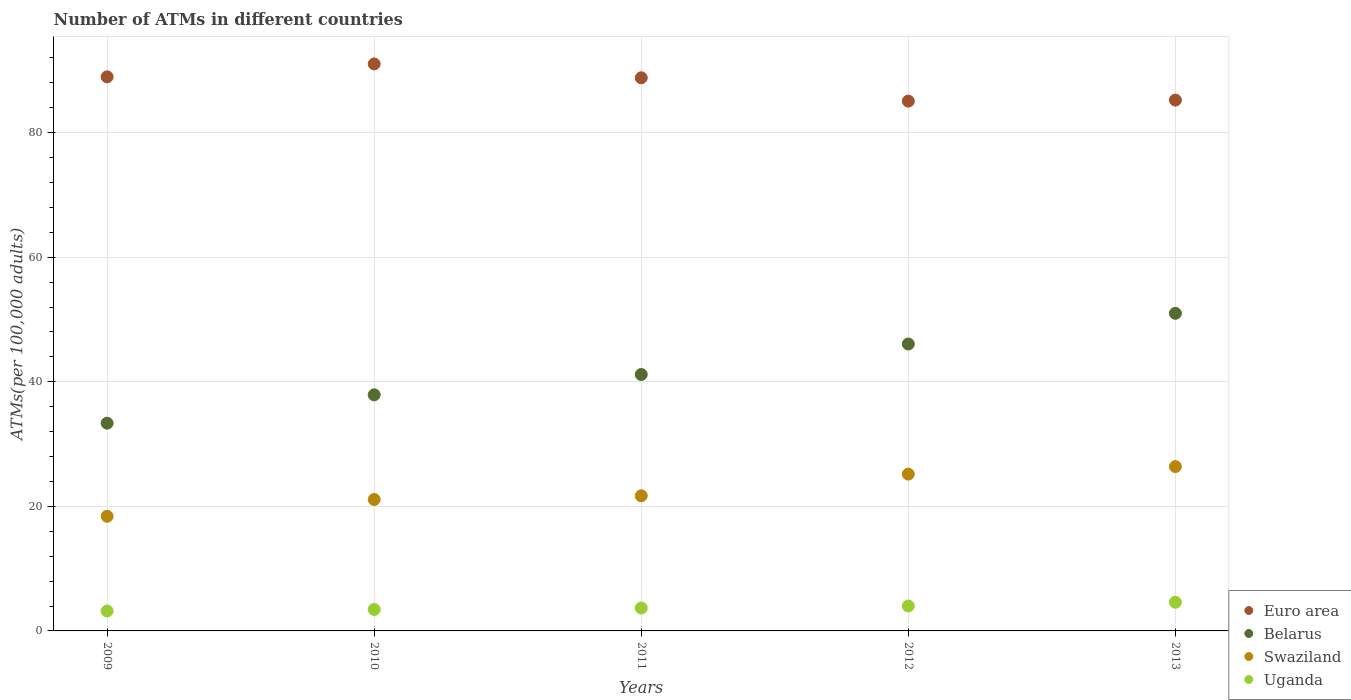Is the number of dotlines equal to the number of legend labels?
Provide a succinct answer. Yes. What is the number of ATMs in Euro area in 2012?
Your response must be concise. 85.06. Across all years, what is the maximum number of ATMs in Uganda?
Offer a terse response. 4.6. Across all years, what is the minimum number of ATMs in Swaziland?
Provide a short and direct response. 18.4. In which year was the number of ATMs in Swaziland maximum?
Your answer should be compact. 2013. What is the total number of ATMs in Uganda in the graph?
Your answer should be very brief. 18.93. What is the difference between the number of ATMs in Belarus in 2010 and that in 2012?
Ensure brevity in your answer.  -8.16. What is the difference between the number of ATMs in Swaziland in 2011 and the number of ATMs in Uganda in 2012?
Ensure brevity in your answer.  17.7. What is the average number of ATMs in Swaziland per year?
Offer a very short reply. 22.55. In the year 2013, what is the difference between the number of ATMs in Swaziland and number of ATMs in Uganda?
Give a very brief answer. 21.78. What is the ratio of the number of ATMs in Swaziland in 2011 to that in 2013?
Offer a terse response. 0.82. What is the difference between the highest and the second highest number of ATMs in Euro area?
Provide a short and direct response. 2.07. What is the difference between the highest and the lowest number of ATMs in Belarus?
Your response must be concise. 17.64. In how many years, is the number of ATMs in Euro area greater than the average number of ATMs in Euro area taken over all years?
Ensure brevity in your answer.  3. Is the sum of the number of ATMs in Euro area in 2009 and 2011 greater than the maximum number of ATMs in Belarus across all years?
Provide a short and direct response. Yes. Is the number of ATMs in Euro area strictly less than the number of ATMs in Belarus over the years?
Provide a succinct answer. No. How many years are there in the graph?
Provide a short and direct response. 5. What is the difference between two consecutive major ticks on the Y-axis?
Offer a very short reply. 20. Does the graph contain any zero values?
Provide a succinct answer. No. Where does the legend appear in the graph?
Your response must be concise. Bottom right. What is the title of the graph?
Your answer should be compact. Number of ATMs in different countries. What is the label or title of the Y-axis?
Offer a terse response. ATMs(per 100,0 adults). What is the ATMs(per 100,000 adults) of Euro area in 2009?
Provide a succinct answer. 88.96. What is the ATMs(per 100,000 adults) in Belarus in 2009?
Offer a very short reply. 33.35. What is the ATMs(per 100,000 adults) in Swaziland in 2009?
Provide a short and direct response. 18.4. What is the ATMs(per 100,000 adults) of Uganda in 2009?
Provide a short and direct response. 3.2. What is the ATMs(per 100,000 adults) in Euro area in 2010?
Provide a short and direct response. 91.03. What is the ATMs(per 100,000 adults) in Belarus in 2010?
Your answer should be compact. 37.9. What is the ATMs(per 100,000 adults) in Swaziland in 2010?
Provide a short and direct response. 21.1. What is the ATMs(per 100,000 adults) of Uganda in 2010?
Provide a succinct answer. 3.45. What is the ATMs(per 100,000 adults) of Euro area in 2011?
Offer a very short reply. 88.81. What is the ATMs(per 100,000 adults) of Belarus in 2011?
Your answer should be compact. 41.17. What is the ATMs(per 100,000 adults) of Swaziland in 2011?
Ensure brevity in your answer.  21.7. What is the ATMs(per 100,000 adults) in Uganda in 2011?
Give a very brief answer. 3.68. What is the ATMs(per 100,000 adults) of Euro area in 2012?
Make the answer very short. 85.06. What is the ATMs(per 100,000 adults) in Belarus in 2012?
Offer a terse response. 46.06. What is the ATMs(per 100,000 adults) of Swaziland in 2012?
Ensure brevity in your answer.  25.18. What is the ATMs(per 100,000 adults) in Uganda in 2012?
Your answer should be very brief. 4. What is the ATMs(per 100,000 adults) in Euro area in 2013?
Provide a succinct answer. 85.23. What is the ATMs(per 100,000 adults) of Belarus in 2013?
Provide a short and direct response. 50.99. What is the ATMs(per 100,000 adults) in Swaziland in 2013?
Provide a short and direct response. 26.38. What is the ATMs(per 100,000 adults) in Uganda in 2013?
Provide a short and direct response. 4.6. Across all years, what is the maximum ATMs(per 100,000 adults) in Euro area?
Provide a short and direct response. 91.03. Across all years, what is the maximum ATMs(per 100,000 adults) of Belarus?
Give a very brief answer. 50.99. Across all years, what is the maximum ATMs(per 100,000 adults) in Swaziland?
Provide a succinct answer. 26.38. Across all years, what is the maximum ATMs(per 100,000 adults) in Uganda?
Provide a succinct answer. 4.6. Across all years, what is the minimum ATMs(per 100,000 adults) in Euro area?
Ensure brevity in your answer.  85.06. Across all years, what is the minimum ATMs(per 100,000 adults) in Belarus?
Make the answer very short. 33.35. Across all years, what is the minimum ATMs(per 100,000 adults) in Swaziland?
Your response must be concise. 18.4. Across all years, what is the minimum ATMs(per 100,000 adults) in Uganda?
Ensure brevity in your answer.  3.2. What is the total ATMs(per 100,000 adults) in Euro area in the graph?
Offer a terse response. 439.07. What is the total ATMs(per 100,000 adults) in Belarus in the graph?
Give a very brief answer. 209.48. What is the total ATMs(per 100,000 adults) of Swaziland in the graph?
Provide a short and direct response. 112.76. What is the total ATMs(per 100,000 adults) in Uganda in the graph?
Keep it short and to the point. 18.93. What is the difference between the ATMs(per 100,000 adults) in Euro area in 2009 and that in 2010?
Give a very brief answer. -2.07. What is the difference between the ATMs(per 100,000 adults) in Belarus in 2009 and that in 2010?
Ensure brevity in your answer.  -4.55. What is the difference between the ATMs(per 100,000 adults) of Swaziland in 2009 and that in 2010?
Ensure brevity in your answer.  -2.7. What is the difference between the ATMs(per 100,000 adults) in Uganda in 2009 and that in 2010?
Make the answer very short. -0.25. What is the difference between the ATMs(per 100,000 adults) in Euro area in 2009 and that in 2011?
Offer a terse response. 0.15. What is the difference between the ATMs(per 100,000 adults) of Belarus in 2009 and that in 2011?
Make the answer very short. -7.82. What is the difference between the ATMs(per 100,000 adults) in Swaziland in 2009 and that in 2011?
Make the answer very short. -3.3. What is the difference between the ATMs(per 100,000 adults) of Uganda in 2009 and that in 2011?
Provide a short and direct response. -0.48. What is the difference between the ATMs(per 100,000 adults) in Euro area in 2009 and that in 2012?
Keep it short and to the point. 3.9. What is the difference between the ATMs(per 100,000 adults) in Belarus in 2009 and that in 2012?
Offer a terse response. -12.71. What is the difference between the ATMs(per 100,000 adults) in Swaziland in 2009 and that in 2012?
Offer a very short reply. -6.77. What is the difference between the ATMs(per 100,000 adults) in Uganda in 2009 and that in 2012?
Provide a succinct answer. -0.8. What is the difference between the ATMs(per 100,000 adults) in Euro area in 2009 and that in 2013?
Provide a succinct answer. 3.73. What is the difference between the ATMs(per 100,000 adults) of Belarus in 2009 and that in 2013?
Your response must be concise. -17.64. What is the difference between the ATMs(per 100,000 adults) in Swaziland in 2009 and that in 2013?
Provide a short and direct response. -7.98. What is the difference between the ATMs(per 100,000 adults) in Uganda in 2009 and that in 2013?
Provide a short and direct response. -1.41. What is the difference between the ATMs(per 100,000 adults) in Euro area in 2010 and that in 2011?
Keep it short and to the point. 2.22. What is the difference between the ATMs(per 100,000 adults) in Belarus in 2010 and that in 2011?
Provide a succinct answer. -3.26. What is the difference between the ATMs(per 100,000 adults) of Swaziland in 2010 and that in 2011?
Offer a terse response. -0.6. What is the difference between the ATMs(per 100,000 adults) of Uganda in 2010 and that in 2011?
Ensure brevity in your answer.  -0.23. What is the difference between the ATMs(per 100,000 adults) in Euro area in 2010 and that in 2012?
Provide a succinct answer. 5.97. What is the difference between the ATMs(per 100,000 adults) in Belarus in 2010 and that in 2012?
Give a very brief answer. -8.16. What is the difference between the ATMs(per 100,000 adults) in Swaziland in 2010 and that in 2012?
Your response must be concise. -4.07. What is the difference between the ATMs(per 100,000 adults) of Uganda in 2010 and that in 2012?
Your answer should be very brief. -0.55. What is the difference between the ATMs(per 100,000 adults) of Euro area in 2010 and that in 2013?
Keep it short and to the point. 5.8. What is the difference between the ATMs(per 100,000 adults) of Belarus in 2010 and that in 2013?
Offer a very short reply. -13.08. What is the difference between the ATMs(per 100,000 adults) in Swaziland in 2010 and that in 2013?
Give a very brief answer. -5.28. What is the difference between the ATMs(per 100,000 adults) of Uganda in 2010 and that in 2013?
Give a very brief answer. -1.16. What is the difference between the ATMs(per 100,000 adults) of Euro area in 2011 and that in 2012?
Offer a very short reply. 3.75. What is the difference between the ATMs(per 100,000 adults) of Belarus in 2011 and that in 2012?
Offer a terse response. -4.9. What is the difference between the ATMs(per 100,000 adults) in Swaziland in 2011 and that in 2012?
Give a very brief answer. -3.48. What is the difference between the ATMs(per 100,000 adults) in Uganda in 2011 and that in 2012?
Ensure brevity in your answer.  -0.32. What is the difference between the ATMs(per 100,000 adults) in Euro area in 2011 and that in 2013?
Provide a succinct answer. 3.58. What is the difference between the ATMs(per 100,000 adults) of Belarus in 2011 and that in 2013?
Provide a short and direct response. -9.82. What is the difference between the ATMs(per 100,000 adults) of Swaziland in 2011 and that in 2013?
Offer a terse response. -4.68. What is the difference between the ATMs(per 100,000 adults) in Uganda in 2011 and that in 2013?
Your answer should be compact. -0.93. What is the difference between the ATMs(per 100,000 adults) of Euro area in 2012 and that in 2013?
Your response must be concise. -0.17. What is the difference between the ATMs(per 100,000 adults) of Belarus in 2012 and that in 2013?
Keep it short and to the point. -4.93. What is the difference between the ATMs(per 100,000 adults) in Swaziland in 2012 and that in 2013?
Give a very brief answer. -1.21. What is the difference between the ATMs(per 100,000 adults) in Uganda in 2012 and that in 2013?
Ensure brevity in your answer.  -0.61. What is the difference between the ATMs(per 100,000 adults) in Euro area in 2009 and the ATMs(per 100,000 adults) in Belarus in 2010?
Your answer should be compact. 51.05. What is the difference between the ATMs(per 100,000 adults) in Euro area in 2009 and the ATMs(per 100,000 adults) in Swaziland in 2010?
Offer a terse response. 67.85. What is the difference between the ATMs(per 100,000 adults) of Euro area in 2009 and the ATMs(per 100,000 adults) of Uganda in 2010?
Provide a short and direct response. 85.51. What is the difference between the ATMs(per 100,000 adults) of Belarus in 2009 and the ATMs(per 100,000 adults) of Swaziland in 2010?
Make the answer very short. 12.25. What is the difference between the ATMs(per 100,000 adults) of Belarus in 2009 and the ATMs(per 100,000 adults) of Uganda in 2010?
Provide a succinct answer. 29.9. What is the difference between the ATMs(per 100,000 adults) in Swaziland in 2009 and the ATMs(per 100,000 adults) in Uganda in 2010?
Make the answer very short. 14.96. What is the difference between the ATMs(per 100,000 adults) of Euro area in 2009 and the ATMs(per 100,000 adults) of Belarus in 2011?
Make the answer very short. 47.79. What is the difference between the ATMs(per 100,000 adults) of Euro area in 2009 and the ATMs(per 100,000 adults) of Swaziland in 2011?
Your answer should be very brief. 67.26. What is the difference between the ATMs(per 100,000 adults) of Euro area in 2009 and the ATMs(per 100,000 adults) of Uganda in 2011?
Offer a very short reply. 85.28. What is the difference between the ATMs(per 100,000 adults) of Belarus in 2009 and the ATMs(per 100,000 adults) of Swaziland in 2011?
Make the answer very short. 11.65. What is the difference between the ATMs(per 100,000 adults) of Belarus in 2009 and the ATMs(per 100,000 adults) of Uganda in 2011?
Your response must be concise. 29.67. What is the difference between the ATMs(per 100,000 adults) in Swaziland in 2009 and the ATMs(per 100,000 adults) in Uganda in 2011?
Your answer should be compact. 14.72. What is the difference between the ATMs(per 100,000 adults) of Euro area in 2009 and the ATMs(per 100,000 adults) of Belarus in 2012?
Offer a terse response. 42.89. What is the difference between the ATMs(per 100,000 adults) in Euro area in 2009 and the ATMs(per 100,000 adults) in Swaziland in 2012?
Make the answer very short. 63.78. What is the difference between the ATMs(per 100,000 adults) in Euro area in 2009 and the ATMs(per 100,000 adults) in Uganda in 2012?
Your response must be concise. 84.96. What is the difference between the ATMs(per 100,000 adults) of Belarus in 2009 and the ATMs(per 100,000 adults) of Swaziland in 2012?
Offer a very short reply. 8.18. What is the difference between the ATMs(per 100,000 adults) in Belarus in 2009 and the ATMs(per 100,000 adults) in Uganda in 2012?
Your response must be concise. 29.35. What is the difference between the ATMs(per 100,000 adults) of Swaziland in 2009 and the ATMs(per 100,000 adults) of Uganda in 2012?
Ensure brevity in your answer.  14.4. What is the difference between the ATMs(per 100,000 adults) of Euro area in 2009 and the ATMs(per 100,000 adults) of Belarus in 2013?
Offer a very short reply. 37.97. What is the difference between the ATMs(per 100,000 adults) of Euro area in 2009 and the ATMs(per 100,000 adults) of Swaziland in 2013?
Your response must be concise. 62.57. What is the difference between the ATMs(per 100,000 adults) in Euro area in 2009 and the ATMs(per 100,000 adults) in Uganda in 2013?
Offer a terse response. 84.35. What is the difference between the ATMs(per 100,000 adults) in Belarus in 2009 and the ATMs(per 100,000 adults) in Swaziland in 2013?
Your response must be concise. 6.97. What is the difference between the ATMs(per 100,000 adults) of Belarus in 2009 and the ATMs(per 100,000 adults) of Uganda in 2013?
Give a very brief answer. 28.75. What is the difference between the ATMs(per 100,000 adults) of Swaziland in 2009 and the ATMs(per 100,000 adults) of Uganda in 2013?
Your response must be concise. 13.8. What is the difference between the ATMs(per 100,000 adults) of Euro area in 2010 and the ATMs(per 100,000 adults) of Belarus in 2011?
Provide a succinct answer. 49.86. What is the difference between the ATMs(per 100,000 adults) in Euro area in 2010 and the ATMs(per 100,000 adults) in Swaziland in 2011?
Provide a short and direct response. 69.33. What is the difference between the ATMs(per 100,000 adults) in Euro area in 2010 and the ATMs(per 100,000 adults) in Uganda in 2011?
Your answer should be very brief. 87.35. What is the difference between the ATMs(per 100,000 adults) in Belarus in 2010 and the ATMs(per 100,000 adults) in Swaziland in 2011?
Keep it short and to the point. 16.2. What is the difference between the ATMs(per 100,000 adults) in Belarus in 2010 and the ATMs(per 100,000 adults) in Uganda in 2011?
Your answer should be compact. 34.23. What is the difference between the ATMs(per 100,000 adults) of Swaziland in 2010 and the ATMs(per 100,000 adults) of Uganda in 2011?
Your answer should be very brief. 17.43. What is the difference between the ATMs(per 100,000 adults) of Euro area in 2010 and the ATMs(per 100,000 adults) of Belarus in 2012?
Provide a short and direct response. 44.97. What is the difference between the ATMs(per 100,000 adults) in Euro area in 2010 and the ATMs(per 100,000 adults) in Swaziland in 2012?
Provide a short and direct response. 65.85. What is the difference between the ATMs(per 100,000 adults) in Euro area in 2010 and the ATMs(per 100,000 adults) in Uganda in 2012?
Offer a terse response. 87.03. What is the difference between the ATMs(per 100,000 adults) of Belarus in 2010 and the ATMs(per 100,000 adults) of Swaziland in 2012?
Your response must be concise. 12.73. What is the difference between the ATMs(per 100,000 adults) in Belarus in 2010 and the ATMs(per 100,000 adults) in Uganda in 2012?
Offer a terse response. 33.9. What is the difference between the ATMs(per 100,000 adults) of Swaziland in 2010 and the ATMs(per 100,000 adults) of Uganda in 2012?
Provide a succinct answer. 17.1. What is the difference between the ATMs(per 100,000 adults) of Euro area in 2010 and the ATMs(per 100,000 adults) of Belarus in 2013?
Provide a succinct answer. 40.04. What is the difference between the ATMs(per 100,000 adults) of Euro area in 2010 and the ATMs(per 100,000 adults) of Swaziland in 2013?
Ensure brevity in your answer.  64.65. What is the difference between the ATMs(per 100,000 adults) in Euro area in 2010 and the ATMs(per 100,000 adults) in Uganda in 2013?
Keep it short and to the point. 86.43. What is the difference between the ATMs(per 100,000 adults) in Belarus in 2010 and the ATMs(per 100,000 adults) in Swaziland in 2013?
Provide a short and direct response. 11.52. What is the difference between the ATMs(per 100,000 adults) in Belarus in 2010 and the ATMs(per 100,000 adults) in Uganda in 2013?
Make the answer very short. 33.3. What is the difference between the ATMs(per 100,000 adults) of Swaziland in 2010 and the ATMs(per 100,000 adults) of Uganda in 2013?
Offer a terse response. 16.5. What is the difference between the ATMs(per 100,000 adults) in Euro area in 2011 and the ATMs(per 100,000 adults) in Belarus in 2012?
Give a very brief answer. 42.74. What is the difference between the ATMs(per 100,000 adults) of Euro area in 2011 and the ATMs(per 100,000 adults) of Swaziland in 2012?
Make the answer very short. 63.63. What is the difference between the ATMs(per 100,000 adults) of Euro area in 2011 and the ATMs(per 100,000 adults) of Uganda in 2012?
Provide a short and direct response. 84.81. What is the difference between the ATMs(per 100,000 adults) of Belarus in 2011 and the ATMs(per 100,000 adults) of Swaziland in 2012?
Keep it short and to the point. 15.99. What is the difference between the ATMs(per 100,000 adults) of Belarus in 2011 and the ATMs(per 100,000 adults) of Uganda in 2012?
Provide a succinct answer. 37.17. What is the difference between the ATMs(per 100,000 adults) in Swaziland in 2011 and the ATMs(per 100,000 adults) in Uganda in 2012?
Ensure brevity in your answer.  17.7. What is the difference between the ATMs(per 100,000 adults) of Euro area in 2011 and the ATMs(per 100,000 adults) of Belarus in 2013?
Provide a succinct answer. 37.82. What is the difference between the ATMs(per 100,000 adults) in Euro area in 2011 and the ATMs(per 100,000 adults) in Swaziland in 2013?
Offer a very short reply. 62.42. What is the difference between the ATMs(per 100,000 adults) in Euro area in 2011 and the ATMs(per 100,000 adults) in Uganda in 2013?
Offer a very short reply. 84.2. What is the difference between the ATMs(per 100,000 adults) of Belarus in 2011 and the ATMs(per 100,000 adults) of Swaziland in 2013?
Provide a succinct answer. 14.78. What is the difference between the ATMs(per 100,000 adults) of Belarus in 2011 and the ATMs(per 100,000 adults) of Uganda in 2013?
Offer a very short reply. 36.56. What is the difference between the ATMs(per 100,000 adults) in Swaziland in 2011 and the ATMs(per 100,000 adults) in Uganda in 2013?
Provide a short and direct response. 17.09. What is the difference between the ATMs(per 100,000 adults) in Euro area in 2012 and the ATMs(per 100,000 adults) in Belarus in 2013?
Provide a succinct answer. 34.07. What is the difference between the ATMs(per 100,000 adults) in Euro area in 2012 and the ATMs(per 100,000 adults) in Swaziland in 2013?
Ensure brevity in your answer.  58.67. What is the difference between the ATMs(per 100,000 adults) of Euro area in 2012 and the ATMs(per 100,000 adults) of Uganda in 2013?
Provide a short and direct response. 80.45. What is the difference between the ATMs(per 100,000 adults) of Belarus in 2012 and the ATMs(per 100,000 adults) of Swaziland in 2013?
Keep it short and to the point. 19.68. What is the difference between the ATMs(per 100,000 adults) of Belarus in 2012 and the ATMs(per 100,000 adults) of Uganda in 2013?
Provide a succinct answer. 41.46. What is the difference between the ATMs(per 100,000 adults) in Swaziland in 2012 and the ATMs(per 100,000 adults) in Uganda in 2013?
Provide a short and direct response. 20.57. What is the average ATMs(per 100,000 adults) of Euro area per year?
Provide a succinct answer. 87.81. What is the average ATMs(per 100,000 adults) in Belarus per year?
Your answer should be compact. 41.9. What is the average ATMs(per 100,000 adults) of Swaziland per year?
Offer a very short reply. 22.55. What is the average ATMs(per 100,000 adults) in Uganda per year?
Offer a terse response. 3.79. In the year 2009, what is the difference between the ATMs(per 100,000 adults) in Euro area and ATMs(per 100,000 adults) in Belarus?
Your answer should be very brief. 55.6. In the year 2009, what is the difference between the ATMs(per 100,000 adults) of Euro area and ATMs(per 100,000 adults) of Swaziland?
Provide a succinct answer. 70.55. In the year 2009, what is the difference between the ATMs(per 100,000 adults) in Euro area and ATMs(per 100,000 adults) in Uganda?
Your answer should be compact. 85.76. In the year 2009, what is the difference between the ATMs(per 100,000 adults) in Belarus and ATMs(per 100,000 adults) in Swaziland?
Give a very brief answer. 14.95. In the year 2009, what is the difference between the ATMs(per 100,000 adults) in Belarus and ATMs(per 100,000 adults) in Uganda?
Ensure brevity in your answer.  30.15. In the year 2009, what is the difference between the ATMs(per 100,000 adults) of Swaziland and ATMs(per 100,000 adults) of Uganda?
Provide a succinct answer. 15.2. In the year 2010, what is the difference between the ATMs(per 100,000 adults) in Euro area and ATMs(per 100,000 adults) in Belarus?
Make the answer very short. 53.13. In the year 2010, what is the difference between the ATMs(per 100,000 adults) in Euro area and ATMs(per 100,000 adults) in Swaziland?
Make the answer very short. 69.93. In the year 2010, what is the difference between the ATMs(per 100,000 adults) of Euro area and ATMs(per 100,000 adults) of Uganda?
Ensure brevity in your answer.  87.58. In the year 2010, what is the difference between the ATMs(per 100,000 adults) of Belarus and ATMs(per 100,000 adults) of Swaziland?
Keep it short and to the point. 16.8. In the year 2010, what is the difference between the ATMs(per 100,000 adults) of Belarus and ATMs(per 100,000 adults) of Uganda?
Your answer should be very brief. 34.46. In the year 2010, what is the difference between the ATMs(per 100,000 adults) in Swaziland and ATMs(per 100,000 adults) in Uganda?
Provide a succinct answer. 17.66. In the year 2011, what is the difference between the ATMs(per 100,000 adults) of Euro area and ATMs(per 100,000 adults) of Belarus?
Make the answer very short. 47.64. In the year 2011, what is the difference between the ATMs(per 100,000 adults) in Euro area and ATMs(per 100,000 adults) in Swaziland?
Keep it short and to the point. 67.11. In the year 2011, what is the difference between the ATMs(per 100,000 adults) in Euro area and ATMs(per 100,000 adults) in Uganda?
Your answer should be compact. 85.13. In the year 2011, what is the difference between the ATMs(per 100,000 adults) of Belarus and ATMs(per 100,000 adults) of Swaziland?
Your response must be concise. 19.47. In the year 2011, what is the difference between the ATMs(per 100,000 adults) of Belarus and ATMs(per 100,000 adults) of Uganda?
Offer a terse response. 37.49. In the year 2011, what is the difference between the ATMs(per 100,000 adults) of Swaziland and ATMs(per 100,000 adults) of Uganda?
Your answer should be very brief. 18.02. In the year 2012, what is the difference between the ATMs(per 100,000 adults) in Euro area and ATMs(per 100,000 adults) in Belarus?
Your response must be concise. 38.99. In the year 2012, what is the difference between the ATMs(per 100,000 adults) in Euro area and ATMs(per 100,000 adults) in Swaziland?
Provide a short and direct response. 59.88. In the year 2012, what is the difference between the ATMs(per 100,000 adults) in Euro area and ATMs(per 100,000 adults) in Uganda?
Make the answer very short. 81.06. In the year 2012, what is the difference between the ATMs(per 100,000 adults) of Belarus and ATMs(per 100,000 adults) of Swaziland?
Keep it short and to the point. 20.89. In the year 2012, what is the difference between the ATMs(per 100,000 adults) in Belarus and ATMs(per 100,000 adults) in Uganda?
Provide a short and direct response. 42.06. In the year 2012, what is the difference between the ATMs(per 100,000 adults) in Swaziland and ATMs(per 100,000 adults) in Uganda?
Offer a very short reply. 21.18. In the year 2013, what is the difference between the ATMs(per 100,000 adults) in Euro area and ATMs(per 100,000 adults) in Belarus?
Give a very brief answer. 34.24. In the year 2013, what is the difference between the ATMs(per 100,000 adults) in Euro area and ATMs(per 100,000 adults) in Swaziland?
Your response must be concise. 58.84. In the year 2013, what is the difference between the ATMs(per 100,000 adults) of Euro area and ATMs(per 100,000 adults) of Uganda?
Your answer should be compact. 80.62. In the year 2013, what is the difference between the ATMs(per 100,000 adults) of Belarus and ATMs(per 100,000 adults) of Swaziland?
Your response must be concise. 24.6. In the year 2013, what is the difference between the ATMs(per 100,000 adults) in Belarus and ATMs(per 100,000 adults) in Uganda?
Give a very brief answer. 46.38. In the year 2013, what is the difference between the ATMs(per 100,000 adults) of Swaziland and ATMs(per 100,000 adults) of Uganda?
Provide a succinct answer. 21.78. What is the ratio of the ATMs(per 100,000 adults) in Euro area in 2009 to that in 2010?
Provide a succinct answer. 0.98. What is the ratio of the ATMs(per 100,000 adults) in Belarus in 2009 to that in 2010?
Provide a short and direct response. 0.88. What is the ratio of the ATMs(per 100,000 adults) in Swaziland in 2009 to that in 2010?
Ensure brevity in your answer.  0.87. What is the ratio of the ATMs(per 100,000 adults) of Uganda in 2009 to that in 2010?
Offer a terse response. 0.93. What is the ratio of the ATMs(per 100,000 adults) in Belarus in 2009 to that in 2011?
Keep it short and to the point. 0.81. What is the ratio of the ATMs(per 100,000 adults) in Swaziland in 2009 to that in 2011?
Your response must be concise. 0.85. What is the ratio of the ATMs(per 100,000 adults) in Uganda in 2009 to that in 2011?
Keep it short and to the point. 0.87. What is the ratio of the ATMs(per 100,000 adults) of Euro area in 2009 to that in 2012?
Provide a short and direct response. 1.05. What is the ratio of the ATMs(per 100,000 adults) in Belarus in 2009 to that in 2012?
Offer a very short reply. 0.72. What is the ratio of the ATMs(per 100,000 adults) of Swaziland in 2009 to that in 2012?
Keep it short and to the point. 0.73. What is the ratio of the ATMs(per 100,000 adults) in Uganda in 2009 to that in 2012?
Give a very brief answer. 0.8. What is the ratio of the ATMs(per 100,000 adults) in Euro area in 2009 to that in 2013?
Your answer should be very brief. 1.04. What is the ratio of the ATMs(per 100,000 adults) of Belarus in 2009 to that in 2013?
Your response must be concise. 0.65. What is the ratio of the ATMs(per 100,000 adults) in Swaziland in 2009 to that in 2013?
Make the answer very short. 0.7. What is the ratio of the ATMs(per 100,000 adults) in Uganda in 2009 to that in 2013?
Make the answer very short. 0.69. What is the ratio of the ATMs(per 100,000 adults) in Belarus in 2010 to that in 2011?
Provide a succinct answer. 0.92. What is the ratio of the ATMs(per 100,000 adults) in Swaziland in 2010 to that in 2011?
Offer a terse response. 0.97. What is the ratio of the ATMs(per 100,000 adults) in Uganda in 2010 to that in 2011?
Offer a very short reply. 0.94. What is the ratio of the ATMs(per 100,000 adults) in Euro area in 2010 to that in 2012?
Provide a succinct answer. 1.07. What is the ratio of the ATMs(per 100,000 adults) in Belarus in 2010 to that in 2012?
Offer a very short reply. 0.82. What is the ratio of the ATMs(per 100,000 adults) of Swaziland in 2010 to that in 2012?
Make the answer very short. 0.84. What is the ratio of the ATMs(per 100,000 adults) of Uganda in 2010 to that in 2012?
Offer a terse response. 0.86. What is the ratio of the ATMs(per 100,000 adults) in Euro area in 2010 to that in 2013?
Keep it short and to the point. 1.07. What is the ratio of the ATMs(per 100,000 adults) of Belarus in 2010 to that in 2013?
Provide a succinct answer. 0.74. What is the ratio of the ATMs(per 100,000 adults) of Swaziland in 2010 to that in 2013?
Offer a terse response. 0.8. What is the ratio of the ATMs(per 100,000 adults) in Uganda in 2010 to that in 2013?
Ensure brevity in your answer.  0.75. What is the ratio of the ATMs(per 100,000 adults) in Euro area in 2011 to that in 2012?
Keep it short and to the point. 1.04. What is the ratio of the ATMs(per 100,000 adults) of Belarus in 2011 to that in 2012?
Give a very brief answer. 0.89. What is the ratio of the ATMs(per 100,000 adults) of Swaziland in 2011 to that in 2012?
Keep it short and to the point. 0.86. What is the ratio of the ATMs(per 100,000 adults) of Uganda in 2011 to that in 2012?
Your response must be concise. 0.92. What is the ratio of the ATMs(per 100,000 adults) of Euro area in 2011 to that in 2013?
Keep it short and to the point. 1.04. What is the ratio of the ATMs(per 100,000 adults) in Belarus in 2011 to that in 2013?
Your answer should be compact. 0.81. What is the ratio of the ATMs(per 100,000 adults) in Swaziland in 2011 to that in 2013?
Keep it short and to the point. 0.82. What is the ratio of the ATMs(per 100,000 adults) of Uganda in 2011 to that in 2013?
Ensure brevity in your answer.  0.8. What is the ratio of the ATMs(per 100,000 adults) of Belarus in 2012 to that in 2013?
Provide a succinct answer. 0.9. What is the ratio of the ATMs(per 100,000 adults) of Swaziland in 2012 to that in 2013?
Offer a very short reply. 0.95. What is the ratio of the ATMs(per 100,000 adults) of Uganda in 2012 to that in 2013?
Ensure brevity in your answer.  0.87. What is the difference between the highest and the second highest ATMs(per 100,000 adults) of Euro area?
Keep it short and to the point. 2.07. What is the difference between the highest and the second highest ATMs(per 100,000 adults) in Belarus?
Give a very brief answer. 4.93. What is the difference between the highest and the second highest ATMs(per 100,000 adults) of Swaziland?
Your response must be concise. 1.21. What is the difference between the highest and the second highest ATMs(per 100,000 adults) in Uganda?
Your answer should be compact. 0.61. What is the difference between the highest and the lowest ATMs(per 100,000 adults) in Euro area?
Keep it short and to the point. 5.97. What is the difference between the highest and the lowest ATMs(per 100,000 adults) in Belarus?
Ensure brevity in your answer.  17.64. What is the difference between the highest and the lowest ATMs(per 100,000 adults) of Swaziland?
Ensure brevity in your answer.  7.98. What is the difference between the highest and the lowest ATMs(per 100,000 adults) in Uganda?
Your answer should be very brief. 1.41. 